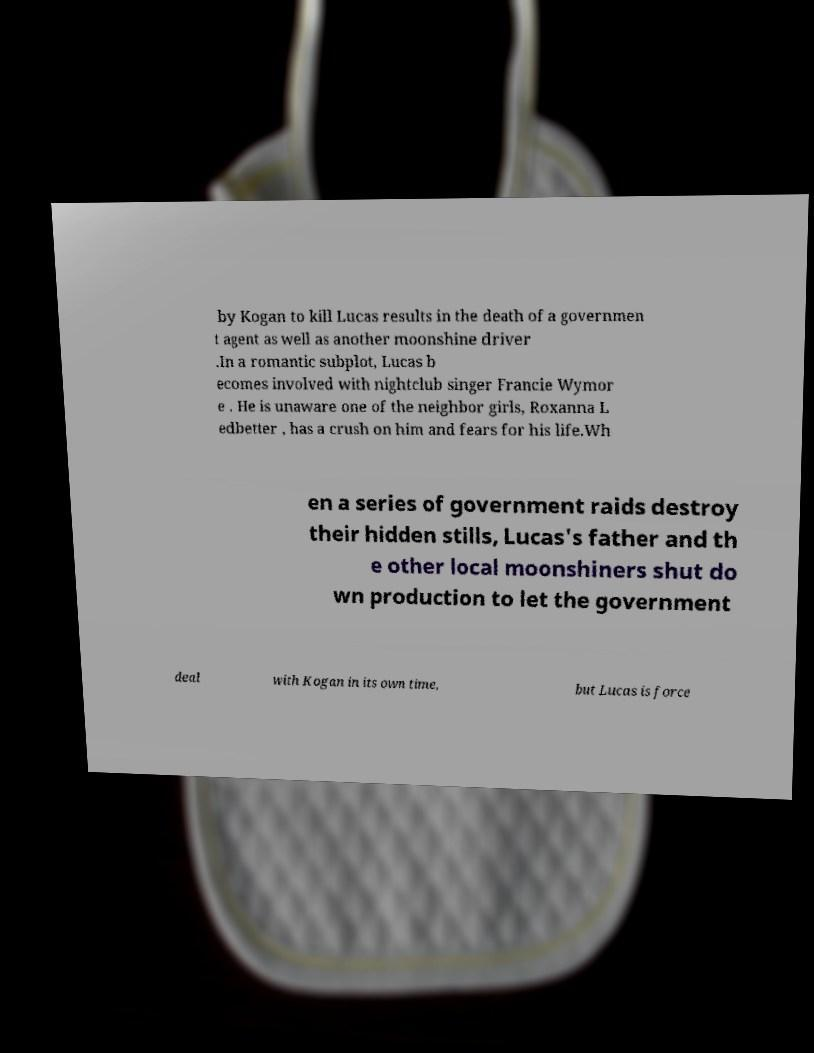Can you read and provide the text displayed in the image?This photo seems to have some interesting text. Can you extract and type it out for me? by Kogan to kill Lucas results in the death of a governmen t agent as well as another moonshine driver .In a romantic subplot, Lucas b ecomes involved with nightclub singer Francie Wymor e . He is unaware one of the neighbor girls, Roxanna L edbetter , has a crush on him and fears for his life.Wh en a series of government raids destroy their hidden stills, Lucas's father and th e other local moonshiners shut do wn production to let the government deal with Kogan in its own time, but Lucas is force 